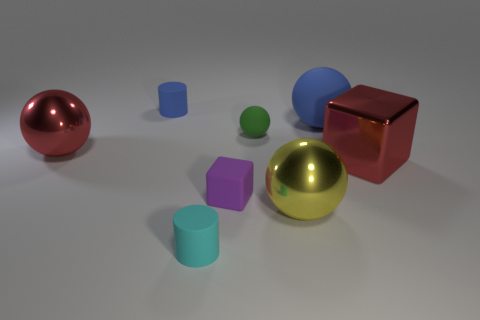How many small things are either blue matte cylinders or cyan rubber cylinders?
Your answer should be compact. 2. What is the ball that is both behind the large red block and in front of the green matte ball made of?
Your response must be concise. Metal. Is the shape of the big shiny thing that is left of the tiny cyan cylinder the same as the matte thing that is in front of the yellow object?
Give a very brief answer. No. What is the shape of the large shiny object that is the same color as the large block?
Offer a very short reply. Sphere. What number of objects are tiny cylinders behind the green object or cyan objects?
Give a very brief answer. 2. Do the green matte thing and the yellow object have the same size?
Give a very brief answer. No. What color is the cylinder that is in front of the small sphere?
Your response must be concise. Cyan. What size is the purple thing that is made of the same material as the small blue cylinder?
Provide a succinct answer. Small. There is a purple thing; is it the same size as the blue rubber object that is left of the tiny purple matte block?
Your response must be concise. Yes. What is the material of the tiny object in front of the big yellow shiny sphere?
Your answer should be compact. Rubber. 